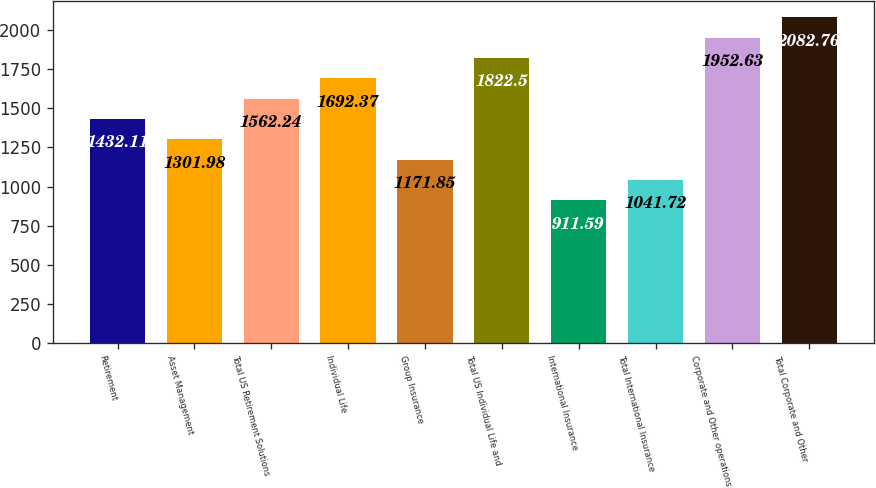<chart> <loc_0><loc_0><loc_500><loc_500><bar_chart><fcel>Retirement<fcel>Asset Management<fcel>Total US Retirement Solutions<fcel>Individual Life<fcel>Group Insurance<fcel>Total US Individual Life and<fcel>International Insurance<fcel>Total International Insurance<fcel>Corporate and Other operations<fcel>Total Corporate and Other<nl><fcel>1432.11<fcel>1301.98<fcel>1562.24<fcel>1692.37<fcel>1171.85<fcel>1822.5<fcel>911.59<fcel>1041.72<fcel>1952.63<fcel>2082.76<nl></chart> 